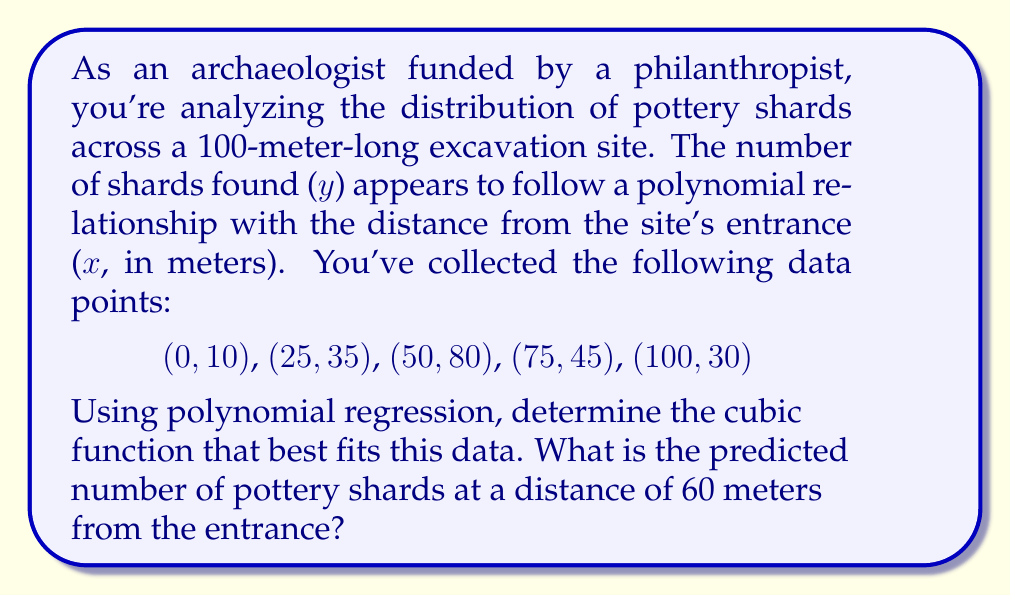Teach me how to tackle this problem. To solve this problem, we'll use cubic polynomial regression to find a function of the form $y = ax^3 + bx^2 + cx + d$ that best fits the given data points.

1. Set up the system of equations:
   For each data point $(x_i, y_i)$, we have:
   $y_i = ax_i^3 + bx_i^2 + cx_i + d$

2. This gives us 5 equations:
   $10 = a(0)^3 + b(0)^2 + c(0) + d$
   $35 = a(25)^3 + b(25)^2 + c(25) + d$
   $80 = a(50)^3 + b(50)^2 + c(50) + d$
   $45 = a(75)^3 + b(75)^2 + c(75) + d$
   $30 = a(100)^3 + b(100)^2 + c(100) + d$

3. Solve this system of equations using a matrix method or a computer algebra system. The solution gives us:
   $a \approx -0.0000384$
   $b \approx 0.00432$
   $c \approx 0.36$
   $d = 10$

4. Therefore, the cubic function that best fits the data is:
   $y = -0.0000384x^3 + 0.00432x^2 + 0.36x + 10$

5. To predict the number of pottery shards at 60 meters, substitute $x = 60$ into this equation:
   $y = -0.0000384(60)^3 + 0.00432(60)^2 + 0.36(60) + 10$
   $= -0.0000384(216000) + 0.00432(3600) + 0.36(60) + 10$
   $= -8.2944 + 15.552 + 21.6 + 10$
   $\approx 38.86$

Therefore, the predicted number of pottery shards at a distance of 60 meters from the entrance is approximately 39 (rounded to the nearest whole number).
Answer: 39 pottery shards 